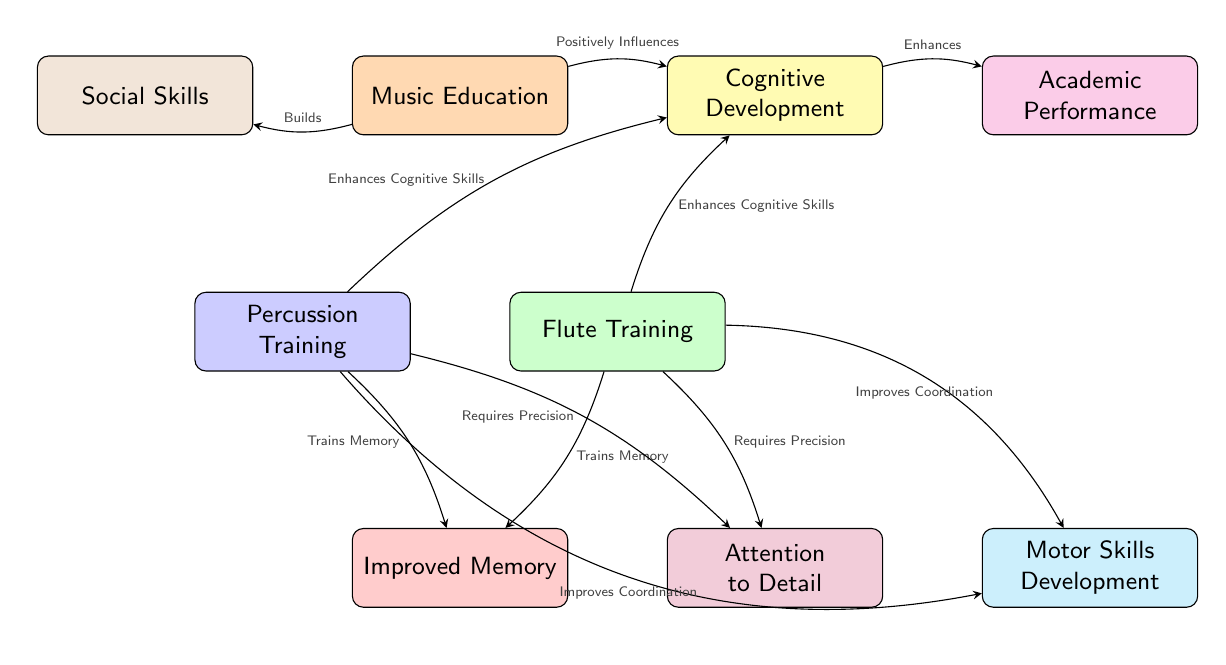What is the central concept of the diagram? The central concept is represented by the top node labeled "Music Education," indicating that it serves as the foundation for the relationships shown in the diagram.
Answer: Music Education How many nodes are connected to "Cognitive Development"? The node "Cognitive Development" is connected to three nodes: "Percussion Training," "Flute Training," and "Academic Performance." Therefore, it has a total of three connections.
Answer: 3 What do "Percussion Training" and "Flute Training" enhance in relation to "Cognitive Development"? Both "Percussion Training" and "Flute Training" are described as enhancing cognitive skills in the context of this diagram, illustrating their positive impact on cognitive development.
Answer: Enhances Cognitive Skills What is the relationship between "Music Education" and "Social Skills"? The arrow indicates that "Music Education" builds "Social Skills," showing a direct influence from music education on social development.
Answer: Builds Which aspect of cognitive skills does both "Percussion Training" and "Flute Training" focus on? Both nodes specify that they contribute to training memory, highlighting a common effect they have on cognitive skills.
Answer: Trains Memory How many skills related to coordination are improved through percussion and flute training? There are two connections leading to "Motor Skills Development" that specify the improvement in coordination, indicating the impact of both types of training.
Answer: 2 What is the overall influence of "Music Education" on academic performance? The diagram shows that "Music Education" positively influences "Academic Performance," suggesting a beneficial link between music education and success in academics.
Answer: Enhances Which node is at the bottom right of the diagram? The node located at the bottom right is labeled "Motor Skills Development," reflecting one of the outcomes associated with both percussion and flute training.
Answer: Motor Skills Development 